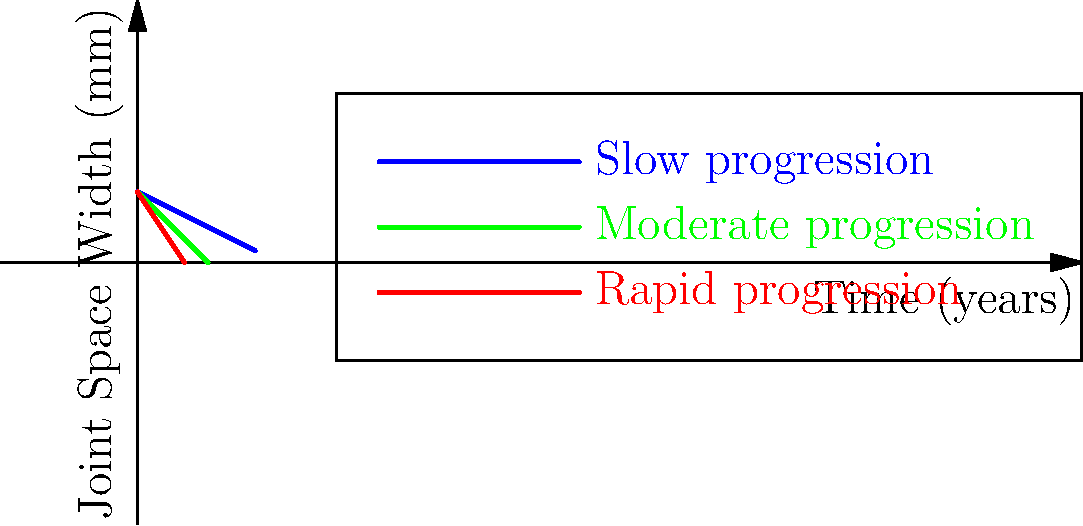Based on the X-ray image analysis of rheumatoid arthritis progression in hand joints over time, which curve represents the most aggressive form of the disease, and approximately how long does it take for the joint space to narrow to 0 mm in this case? To interpret this graph and answer the question, let's follow these steps:

1. Understand the graph:
   - The x-axis represents time in years.
   - The y-axis represents joint space width in millimeters.
   - There are three curves representing different rates of disease progression.

2. Identify the curves:
   - Blue curve: Slow progression
   - Green curve: Moderate progression
   - Red curve: Rapid progression

3. Determine the most aggressive form:
   - The most aggressive form will show the fastest decrease in joint space width over time.
   - The red curve has the steepest slope, indicating the most rapid progression.

4. Calculate the time to reach 0 mm joint space for the red curve:
   - The equation for the red curve is approximately $y = 3 - 1.5x$
   - We need to solve for x when y = 0:
     $0 = 3 - 1.5x$
     $1.5x = 3$
     $x = 2$

5. Interpret the result:
   - It takes approximately 2 years for the joint space to narrow to 0 mm in the most aggressive case.
Answer: Red curve; 2 years 